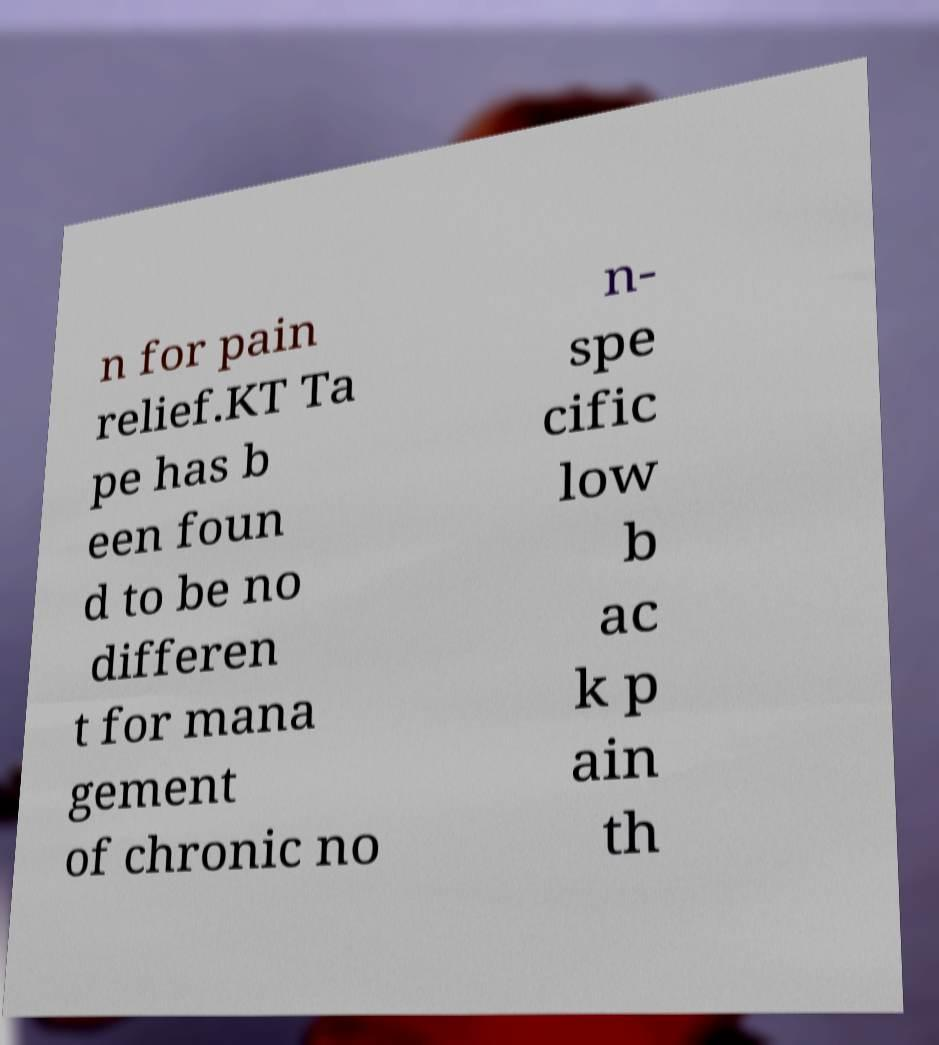I need the written content from this picture converted into text. Can you do that? n for pain relief.KT Ta pe has b een foun d to be no differen t for mana gement of chronic no n- spe cific low b ac k p ain th 